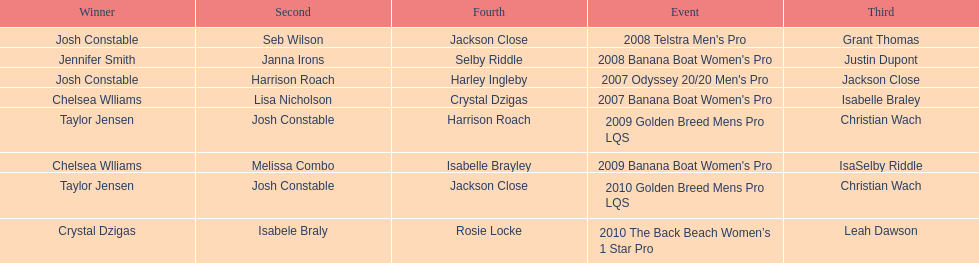What is the total number of times chelsea williams was the winner between 2007 and 2010? 2. 